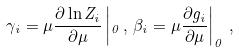Convert formula to latex. <formula><loc_0><loc_0><loc_500><loc_500>\gamma _ { i } = \mu \frac { \partial \ln Z _ { i } } { \partial \mu } \left | _ { 0 } \, , \, \beta _ { i } = \mu \frac { \partial g _ { i } } { \partial \mu } \right | _ { 0 } \, , \,</formula> 